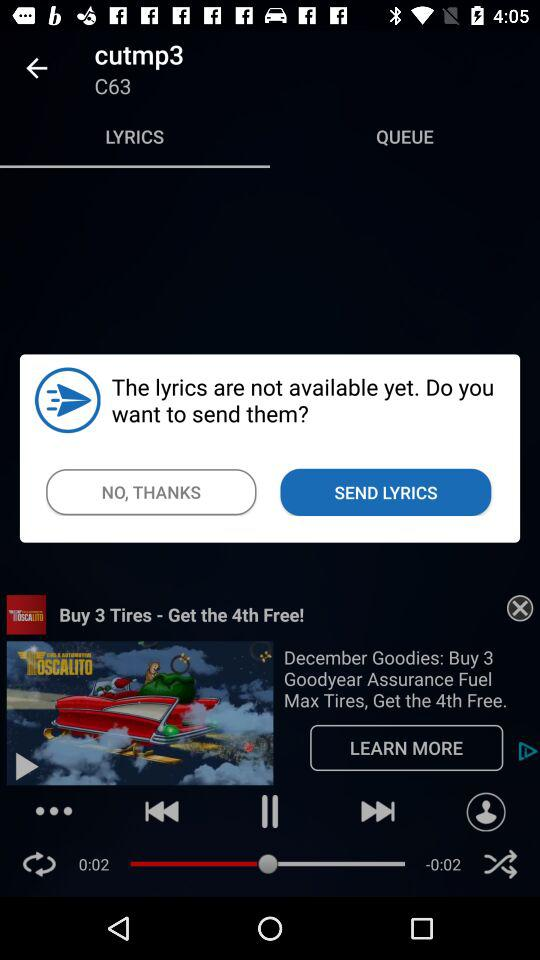How many more seconds are left in the song?
Answer the question using a single word or phrase. 0:02 